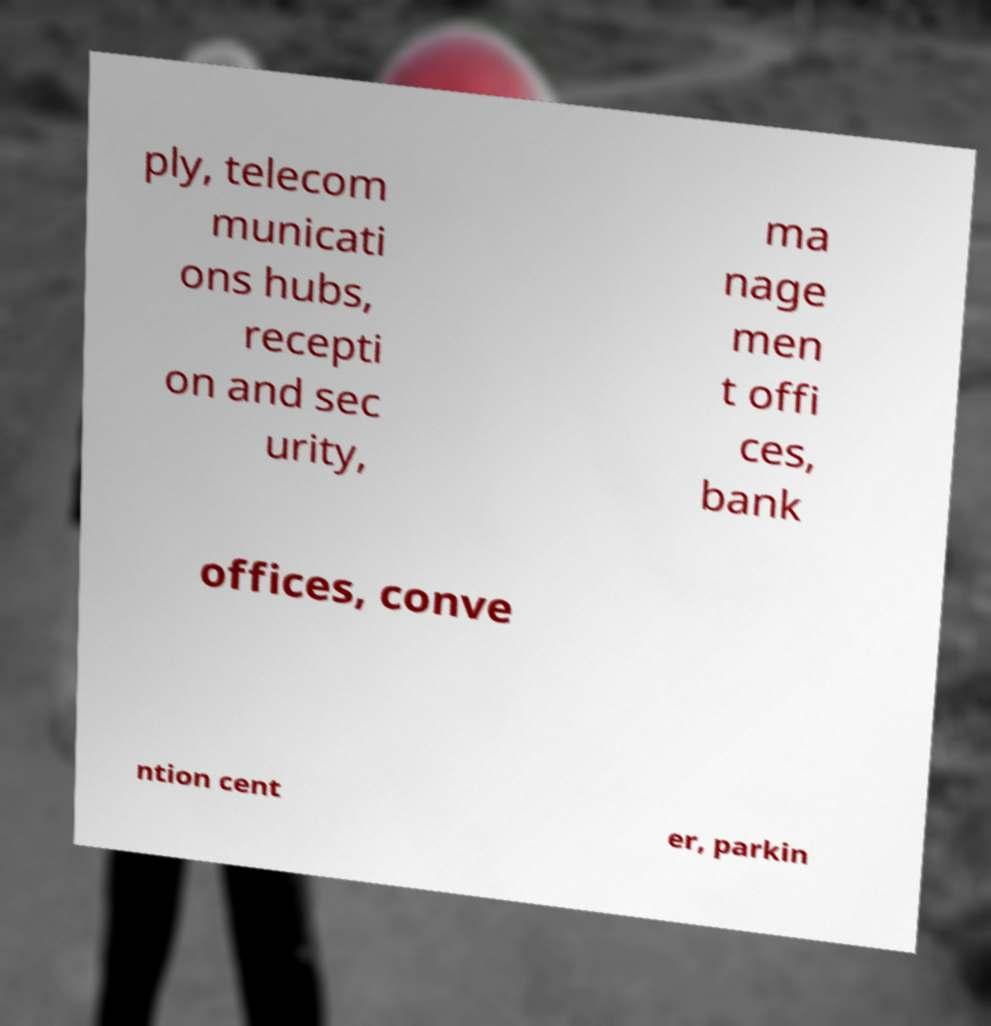Could you assist in decoding the text presented in this image and type it out clearly? ply, telecom municati ons hubs, recepti on and sec urity, ma nage men t offi ces, bank offices, conve ntion cent er, parkin 